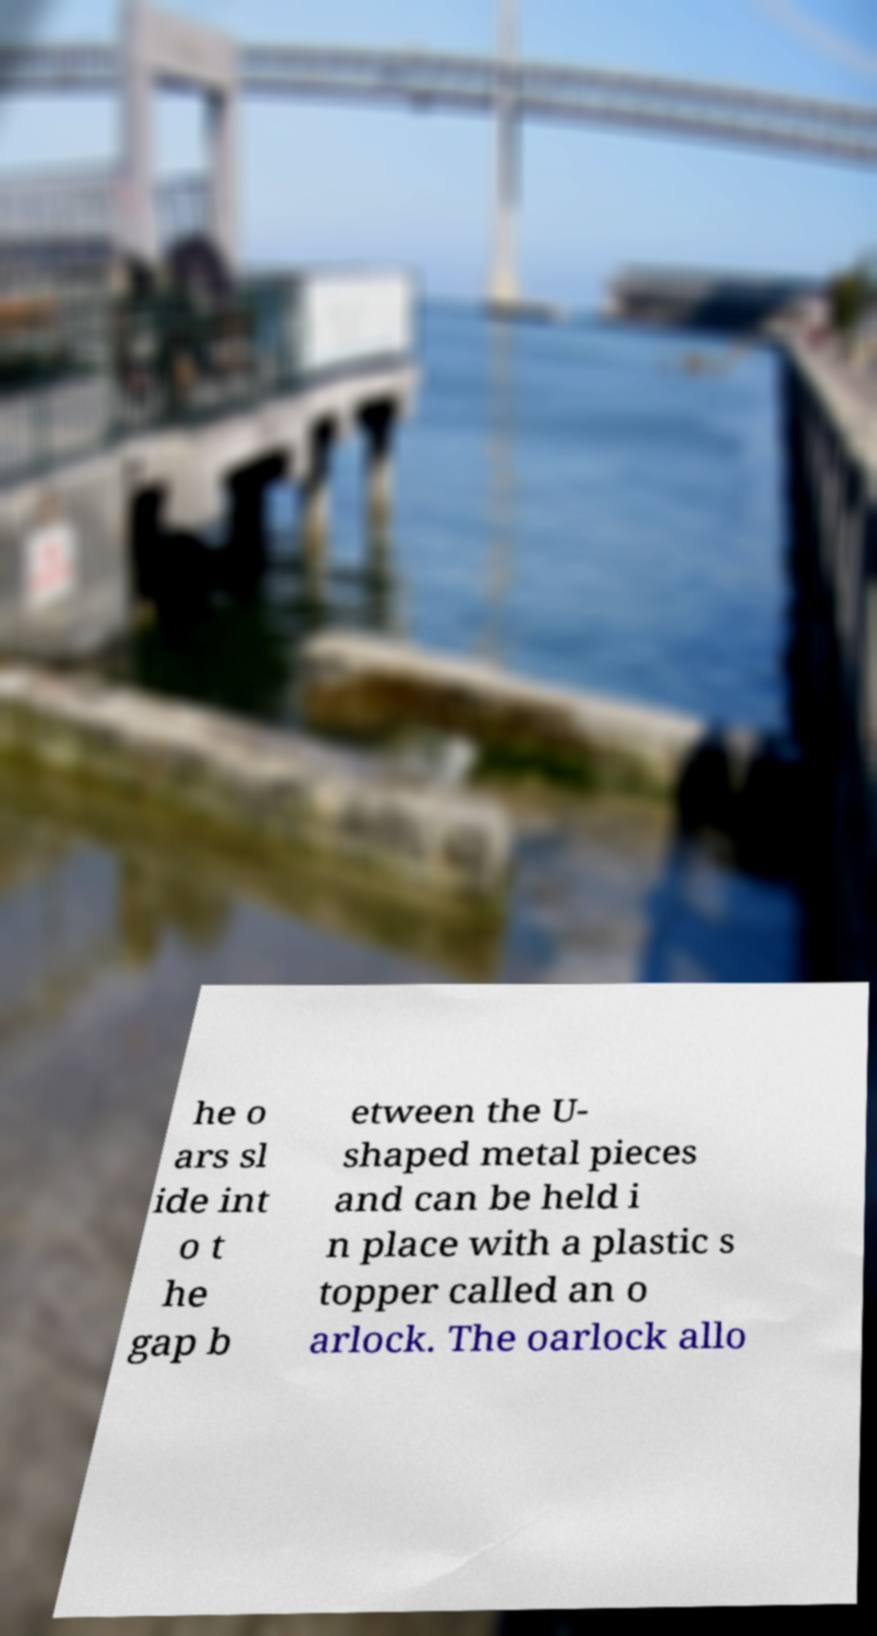Could you extract and type out the text from this image? he o ars sl ide int o t he gap b etween the U- shaped metal pieces and can be held i n place with a plastic s topper called an o arlock. The oarlock allo 